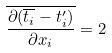<formula> <loc_0><loc_0><loc_500><loc_500>\overline { \frac { \partial ( \overline { t _ { i } } - t _ { i } ^ { \prime } ) } { \partial x _ { i } } } = 2</formula> 